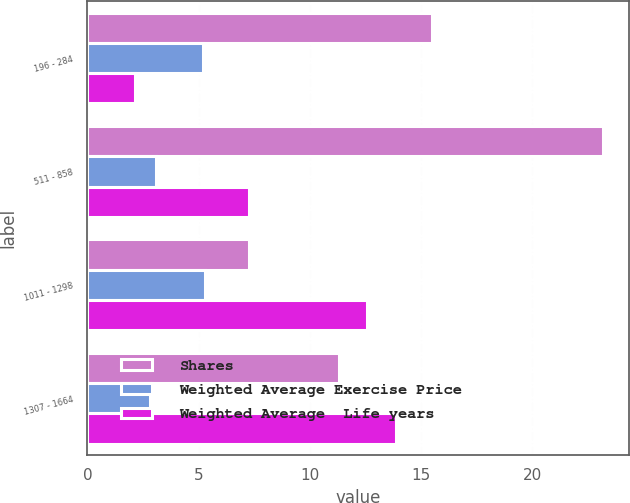<chart> <loc_0><loc_0><loc_500><loc_500><stacked_bar_chart><ecel><fcel>196 - 284<fcel>511 - 858<fcel>1011 - 1298<fcel>1307 - 1664<nl><fcel>Shares<fcel>15.5<fcel>23.2<fcel>7.29<fcel>11.3<nl><fcel>Weighted Average Exercise Price<fcel>5.2<fcel>3.1<fcel>5.3<fcel>2.8<nl><fcel>Weighted Average  Life years<fcel>2.16<fcel>7.29<fcel>12.58<fcel>13.86<nl></chart> 